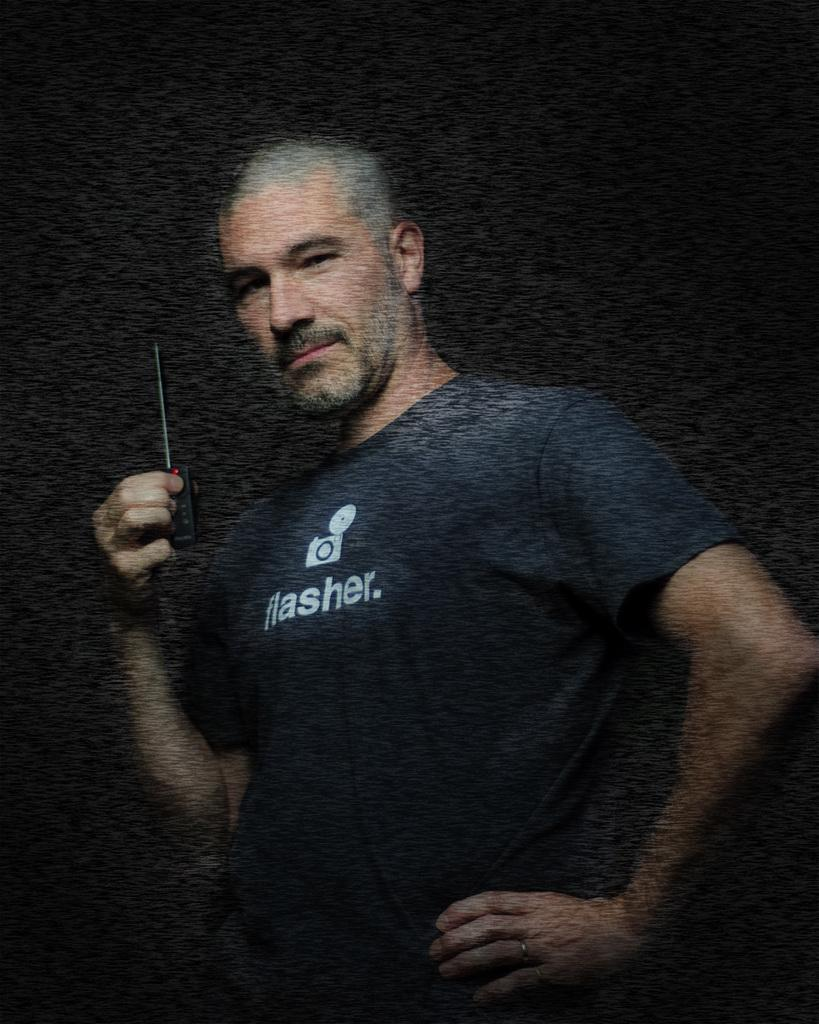Who is present in the image? There is a person in the image. What type of clothing is the person wearing? The person is wearing a t-shirt. What is the person holding in their hand? The person is holding a device in their hand. What theory is the person discussing with the substance in the image? There is no substance or discussion of a theory present in the image; it only shows a person wearing a t-shirt and holding a device. 